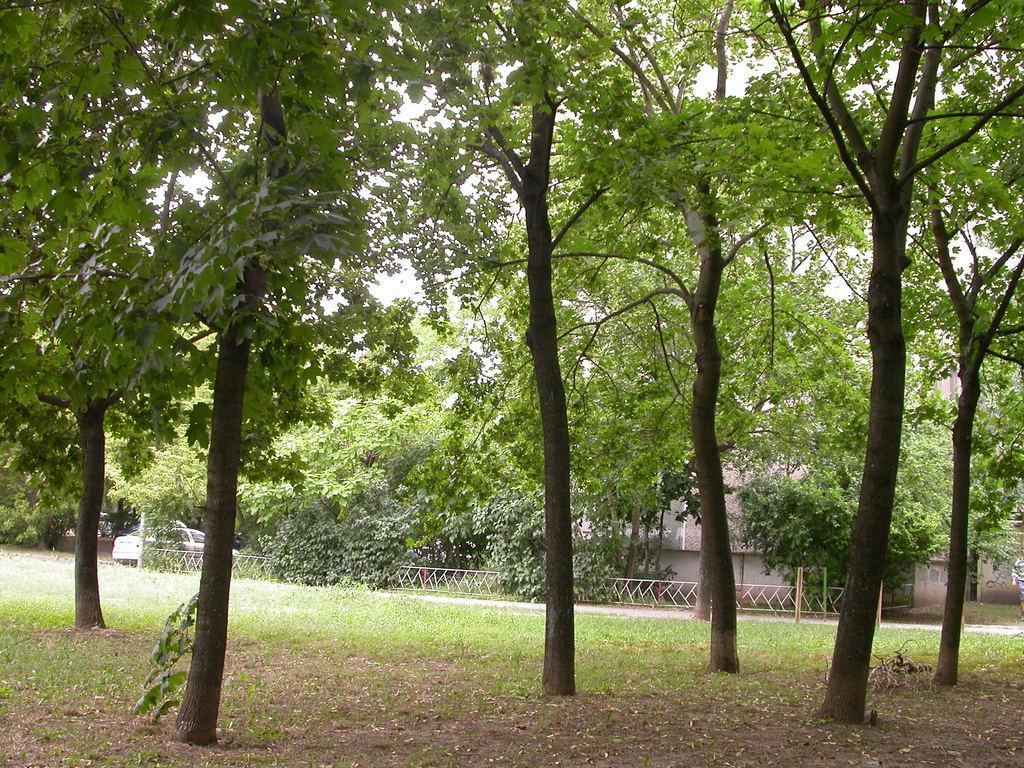Describe this image in one or two sentences. This image is taken outdoors. At the bottom of the image there is a ground with grass on it and there are a few trees. In the background there is a house and there are many trees and plants. A car is parked on the ground. 